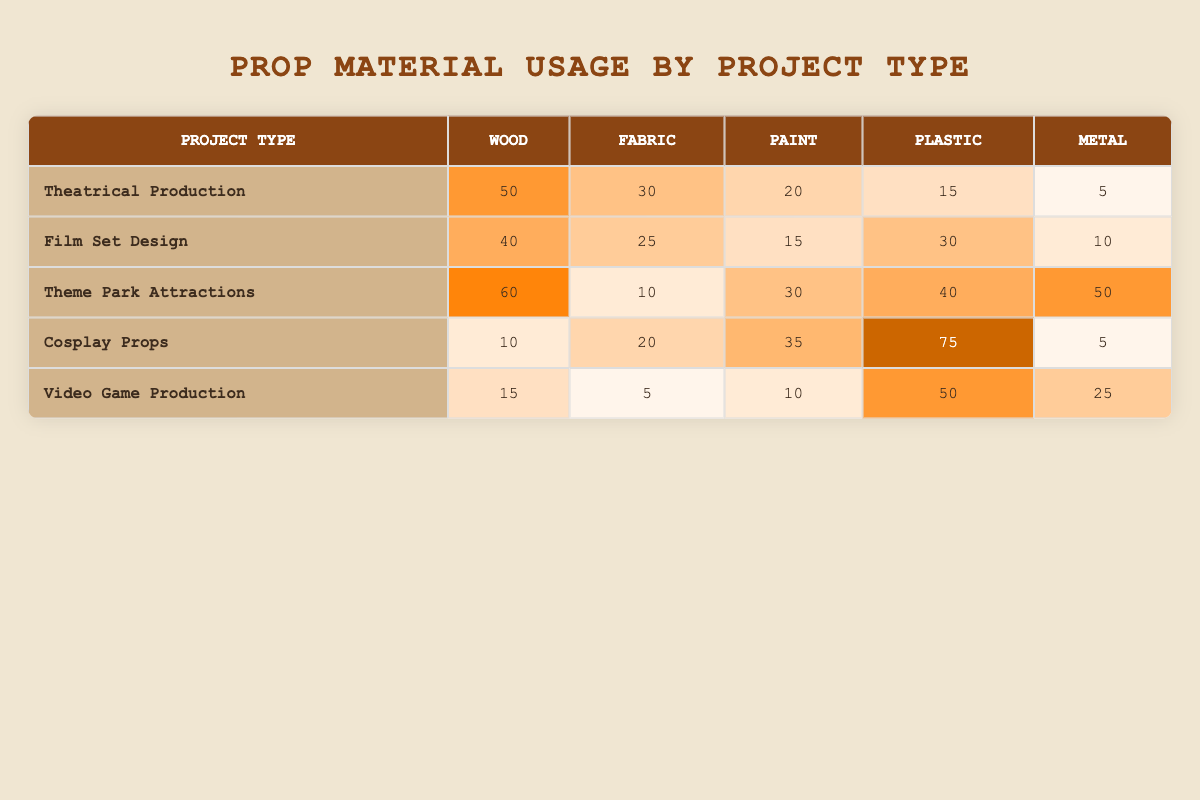What project type uses the most Wood? Looking at the Wood column, Theatrical Production has the highest value at 50.
Answer: Theatrical Production Which project type has the highest total material usage? Calculate the total materials for each project type: Theatrical Production (50+30+20+15+5=120), Film Set Design (40+25+15+30+10=120), Theme Park Attractions (60+10+30+40+50=190), Cosplay Props (10+20+35+75+5=145), Video Game Production (15+5+10+50+25=105). Theme Park Attractions has the highest at 190.
Answer: Theme Park Attractions Does Film Set Design use more Fabric than Cosplay Props? Film Set Design uses 25 Fabric while Cosplay Props uses 20. Since 25 is greater than 20, the statement is true.
Answer: Yes What is the total usage of Plastic across all projects? Sum the Plastic values: 15 (Theatrical Production) + 30 (Film Set Design) + 40 (Theme Park Attractions) + 75 (Cosplay Props) + 50 (Video Game Production) = 210.
Answer: 210 Which project type uses the least amount of Metal? Viewing the Metal column, Cosplay Props and Theatrical Production both have the lowest value at 5, but since Cosplay Props has a lower total material usage, it is the least.
Answer: Cosplay Props What is the difference in Fabric usage between Theme Park Attractions and Video Game Production? Theme Park Attractions uses 10 Fabric, and Video Game Production uses 5 Fabric. The difference is 10 - 5 = 5.
Answer: 5 Are there more materials used in Cosplay Props compared to Film Set Design? Total usage for Cosplay Props is 145, and for Film Set Design it is 120. Since 145 is more than 120, the statement is true.
Answer: Yes What material is most heavily used in Cosplay Props? In the Cosplay Props row, the highest value is 75 for Plastic.
Answer: Plastic 